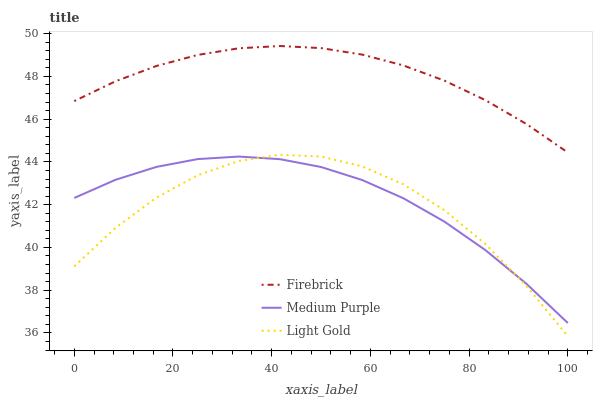Does Firebrick have the minimum area under the curve?
Answer yes or no. No. Does Light Gold have the maximum area under the curve?
Answer yes or no. No. Is Light Gold the smoothest?
Answer yes or no. No. Is Firebrick the roughest?
Answer yes or no. No. Does Firebrick have the lowest value?
Answer yes or no. No. Does Light Gold have the highest value?
Answer yes or no. No. Is Medium Purple less than Firebrick?
Answer yes or no. Yes. Is Firebrick greater than Medium Purple?
Answer yes or no. Yes. Does Medium Purple intersect Firebrick?
Answer yes or no. No. 